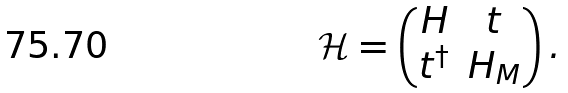Convert formula to latex. <formula><loc_0><loc_0><loc_500><loc_500>\mathcal { H } = \begin{pmatrix} H & t \\ t ^ { \dagger } & H _ { M } \end{pmatrix} .</formula> 